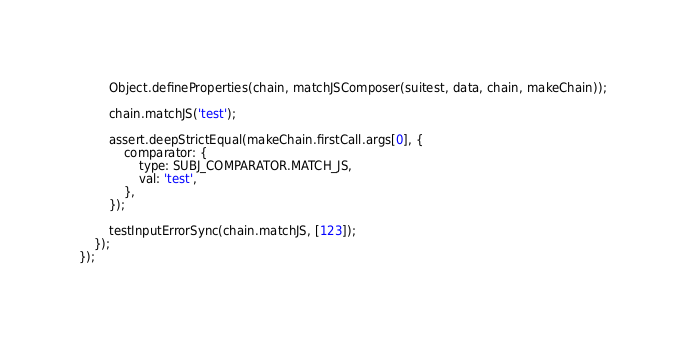Convert code to text. <code><loc_0><loc_0><loc_500><loc_500><_JavaScript_>		Object.defineProperties(chain, matchJSComposer(suitest, data, chain, makeChain));

		chain.matchJS('test');

		assert.deepStrictEqual(makeChain.firstCall.args[0], {
			comparator: {
				type: SUBJ_COMPARATOR.MATCH_JS,
				val: 'test',
			},
		});

		testInputErrorSync(chain.matchJS, [123]);
	});
});
</code> 